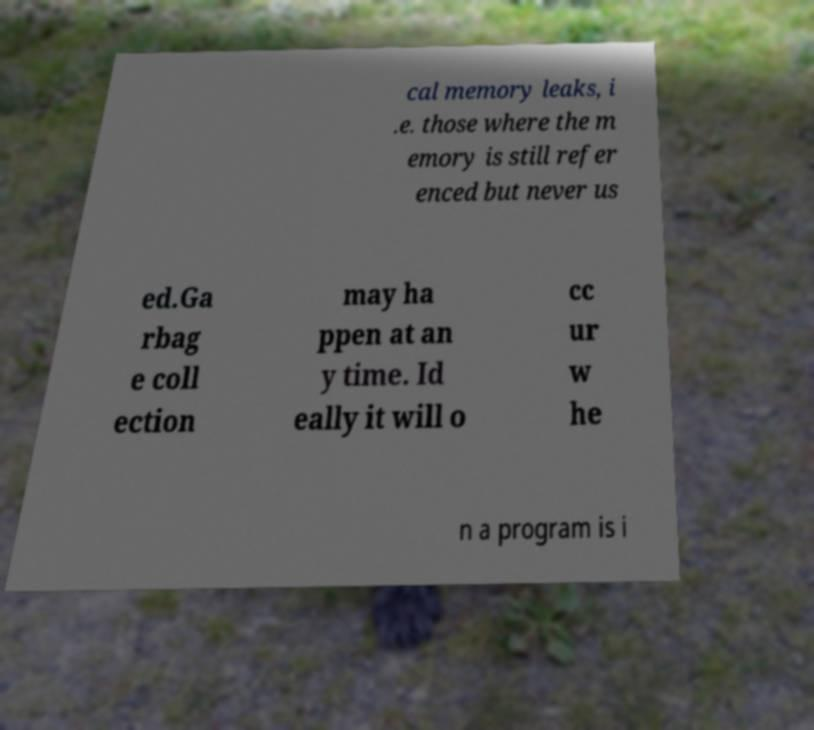For documentation purposes, I need the text within this image transcribed. Could you provide that? cal memory leaks, i .e. those where the m emory is still refer enced but never us ed.Ga rbag e coll ection may ha ppen at an y time. Id eally it will o cc ur w he n a program is i 